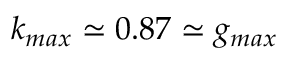<formula> <loc_0><loc_0><loc_500><loc_500>k _ { \max } \simeq 0 . 8 7 \simeq g _ { \max }</formula> 